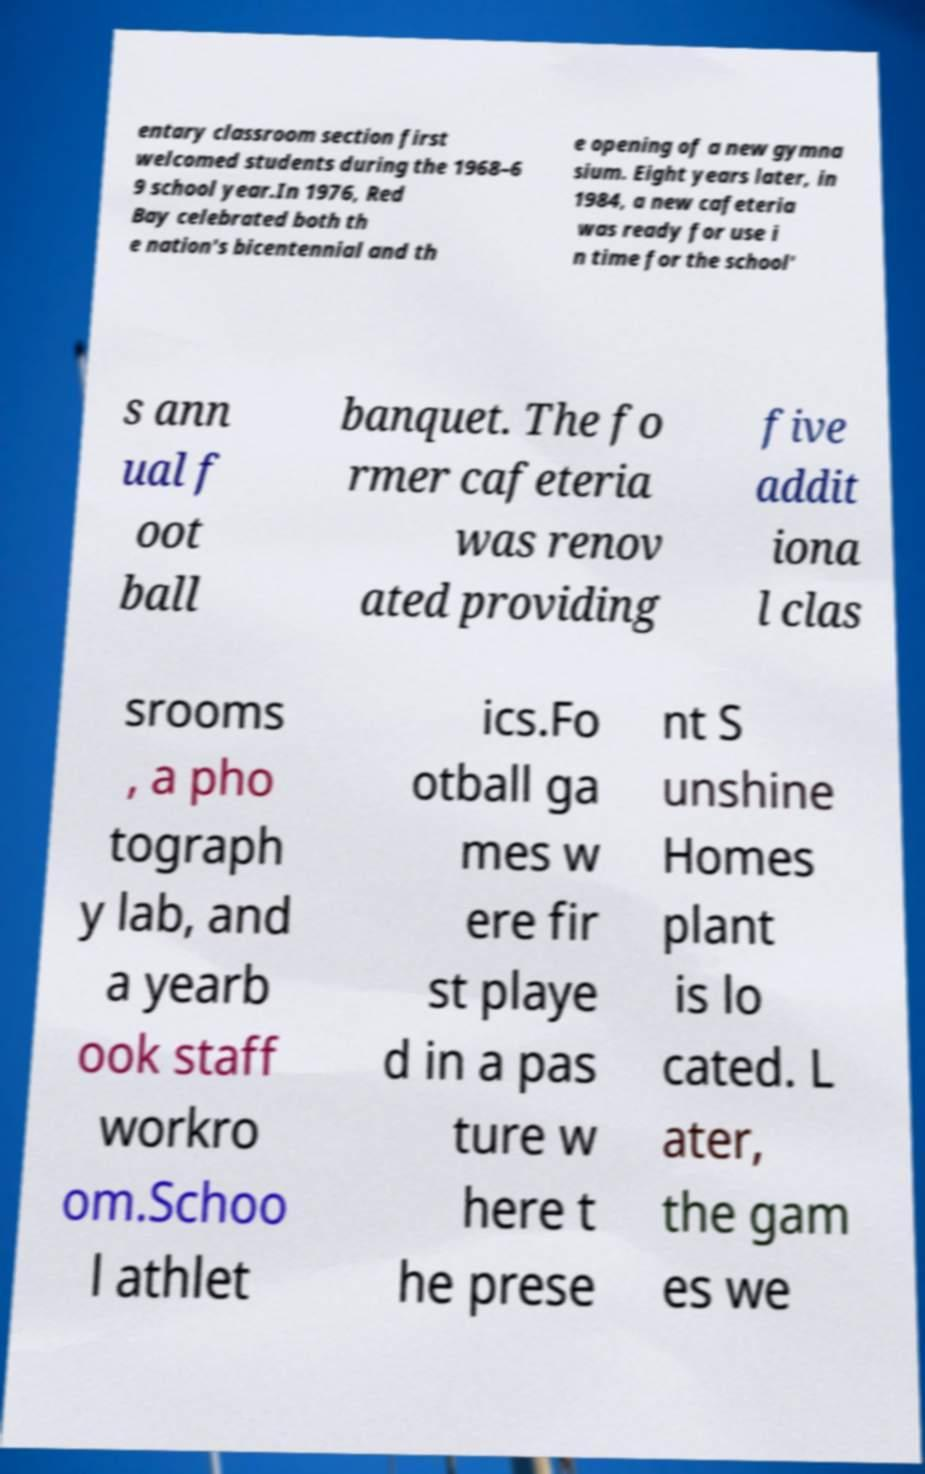For documentation purposes, I need the text within this image transcribed. Could you provide that? entary classroom section first welcomed students during the 1968–6 9 school year.In 1976, Red Bay celebrated both th e nation's bicentennial and th e opening of a new gymna sium. Eight years later, in 1984, a new cafeteria was ready for use i n time for the school' s ann ual f oot ball banquet. The fo rmer cafeteria was renov ated providing five addit iona l clas srooms , a pho tograph y lab, and a yearb ook staff workro om.Schoo l athlet ics.Fo otball ga mes w ere fir st playe d in a pas ture w here t he prese nt S unshine Homes plant is lo cated. L ater, the gam es we 